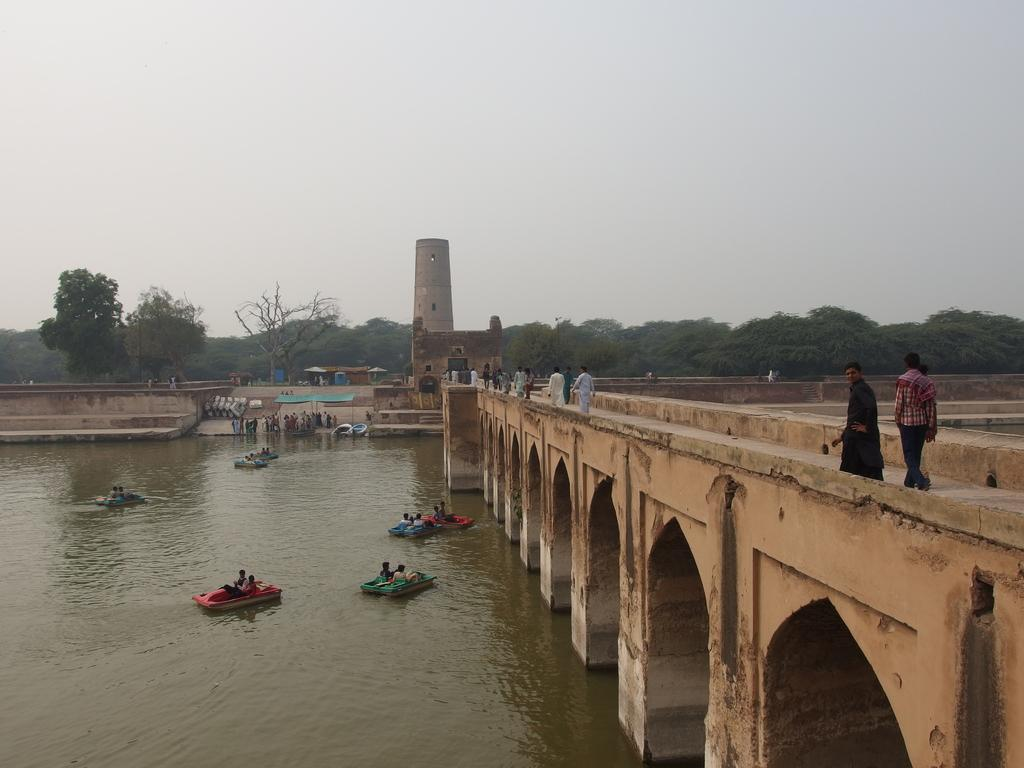What are the people in the image doing? The people in the image are sitting in boats and walking. What is the primary setting of the image? There is water visible in the image, and a bridge is present in the image. What can be seen in the background of the image? There are buildings, people, trees, and the sky visible in the background of the image. What type of sense can be seen in the image? There is no sense present in the image; it is a visual representation of people in boats, walking, and the surrounding environment. 